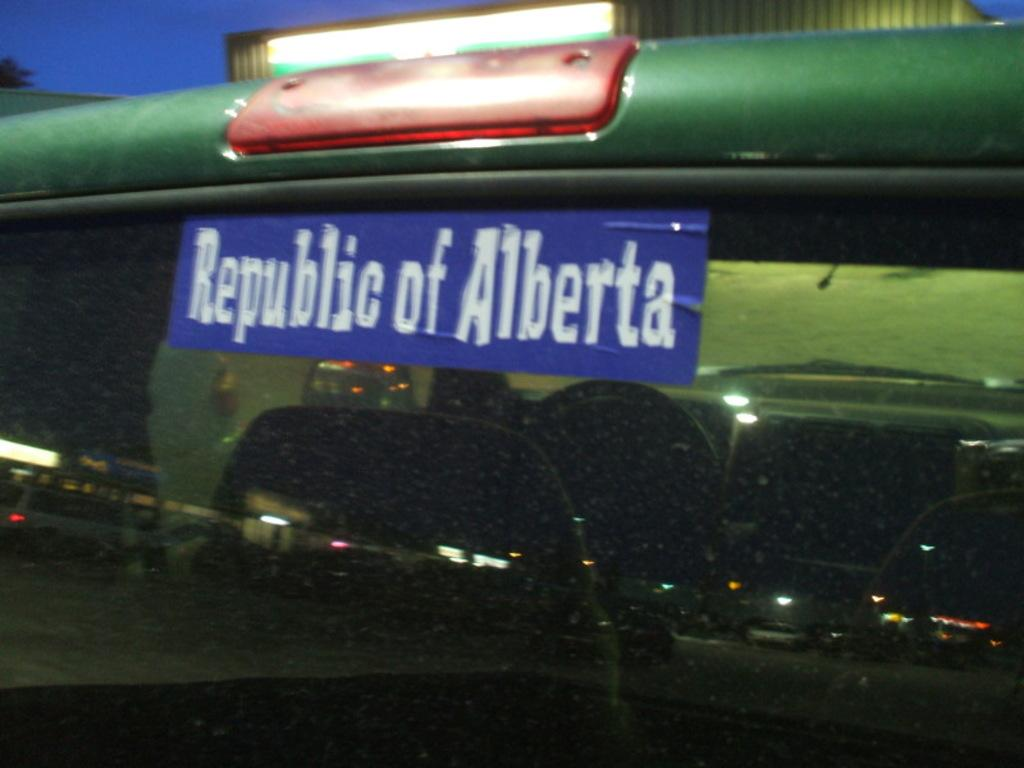What color is the sticker on the glass in the image? The sticker on the glass is violet in color. What is the purpose of the glass in the image? The glass has seats, suggesting it is a type of seating area or structure. What is located near the glass in the image? There is a light near the glass. What can be seen in the background of the image? The sky is visible in the background of the image. What type of cloth is draped over the stage in the image? There is no stage or cloth present in the image; it features a glass with a violet sticker, seats, a light, and a visible sky in the background. What color are the shoes worn by the person sitting on the glass? There are no people or shoes visible in the image. 